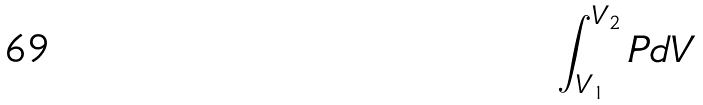<formula> <loc_0><loc_0><loc_500><loc_500>\int _ { V _ { 1 } } ^ { V _ { 2 } } P d V</formula> 